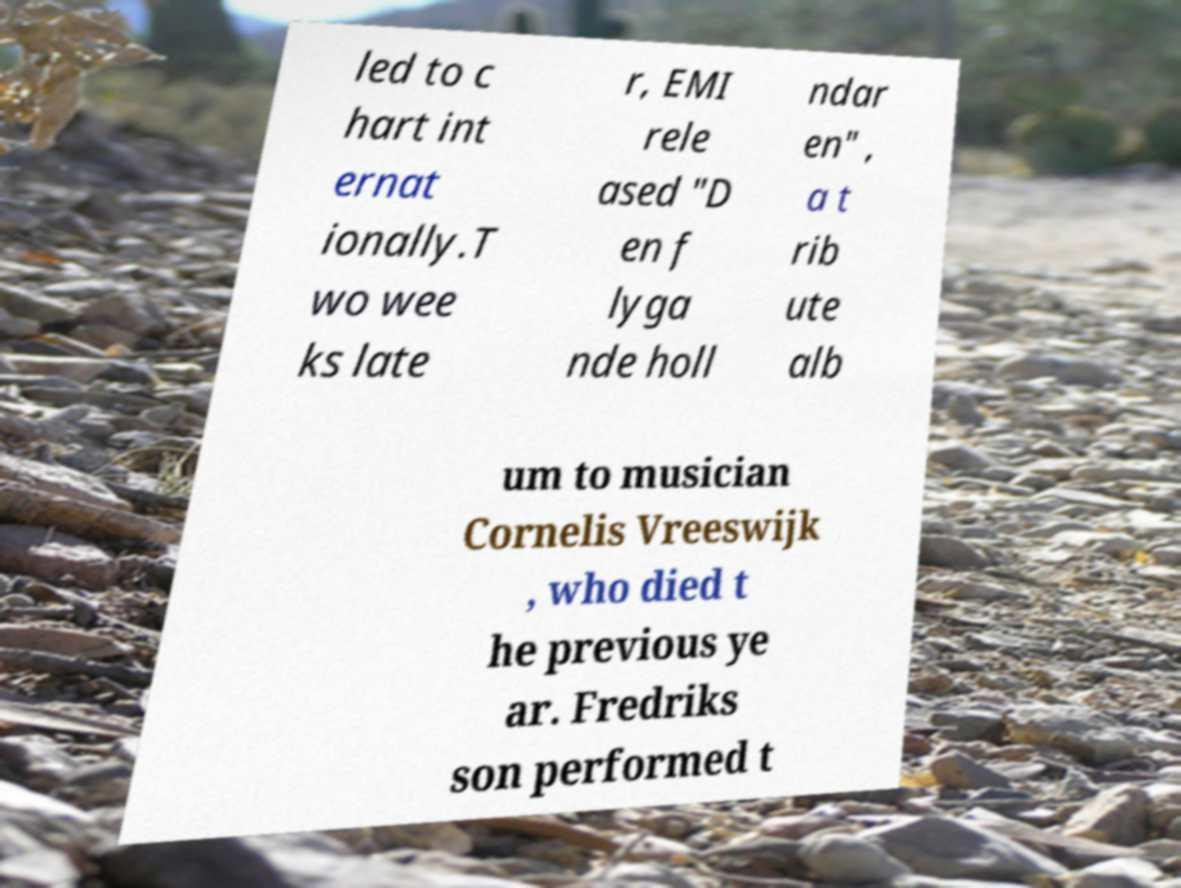Could you assist in decoding the text presented in this image and type it out clearly? led to c hart int ernat ionally.T wo wee ks late r, EMI rele ased "D en f lyga nde holl ndar en" , a t rib ute alb um to musician Cornelis Vreeswijk , who died t he previous ye ar. Fredriks son performed t 